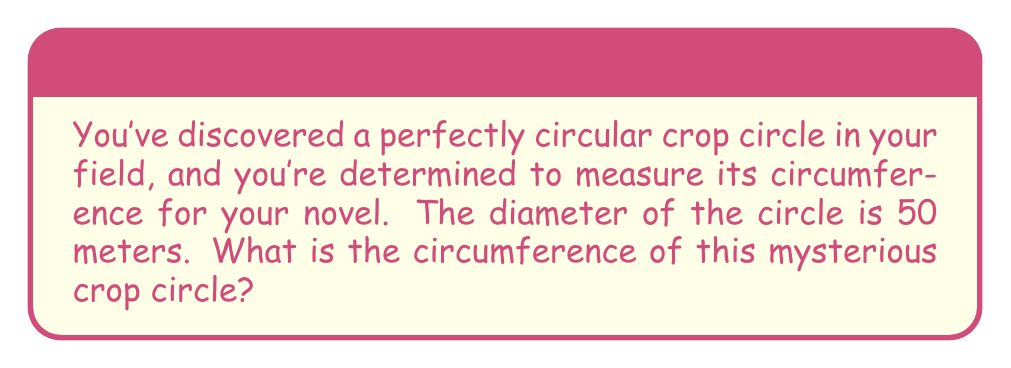Provide a solution to this math problem. To find the circumference of a circle, we use the formula:

$$C = \pi d$$

Where:
$C$ = circumference
$\pi$ = pi (approximately 3.14159)
$d$ = diameter

Given:
$d = 50$ meters

Step 1: Substitute the known values into the formula.
$$C = \pi \cdot 50$$

Step 2: Multiply $\pi$ by 50.
$$C \approx 3.14159 \cdot 50 \approx 157.0795$$

Step 3: Round to two decimal places for a practical measurement.
$$C \approx 157.08\text{ meters}$$

[asy]
import geometry;

size(200);
draw(circle((0,0), 50), linewidth(1));
draw((0,0)--(50,0), arrow=Arrow(TeXHead));
label("50 m", (25,5), N);
label("Crop Circle", (0,0), S);
[/asy]
Answer: $157.08\text{ meters}$ 